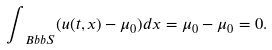Convert formula to latex. <formula><loc_0><loc_0><loc_500><loc_500>\int _ { \ B b b S } ( u ( t , x ) - \mu _ { 0 } ) d x = \mu _ { 0 } - \mu _ { 0 } = 0 .</formula> 